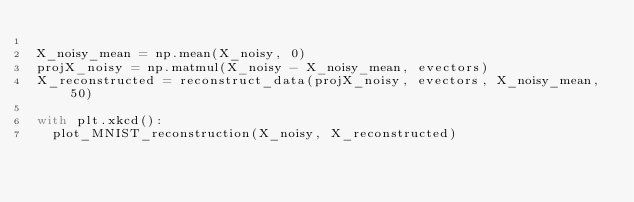Convert code to text. <code><loc_0><loc_0><loc_500><loc_500><_Python_>
X_noisy_mean = np.mean(X_noisy, 0)
projX_noisy = np.matmul(X_noisy - X_noisy_mean, evectors)
X_reconstructed = reconstruct_data(projX_noisy, evectors, X_noisy_mean, 50)

with plt.xkcd():
  plot_MNIST_reconstruction(X_noisy, X_reconstructed)</code> 